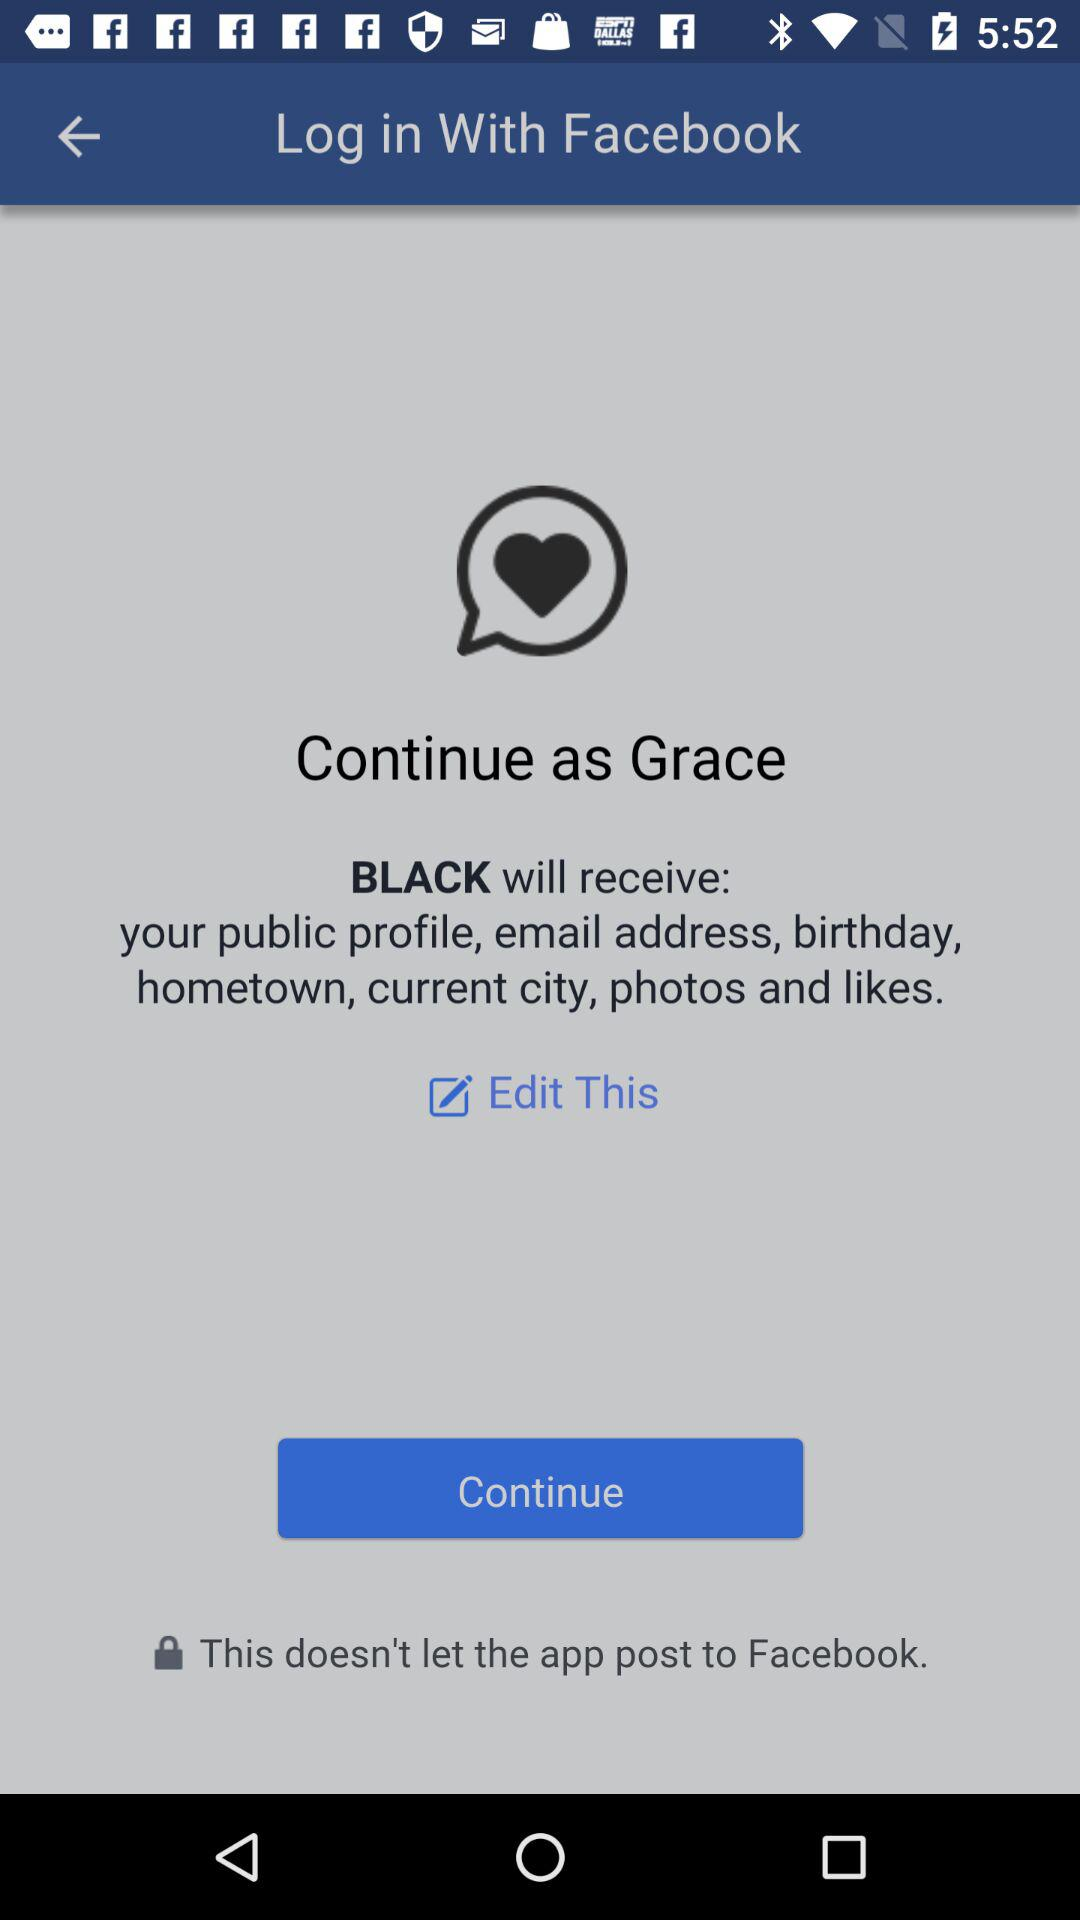What informations can we edit?
When the provided information is insufficient, respond with <no answer>. <no answer> 